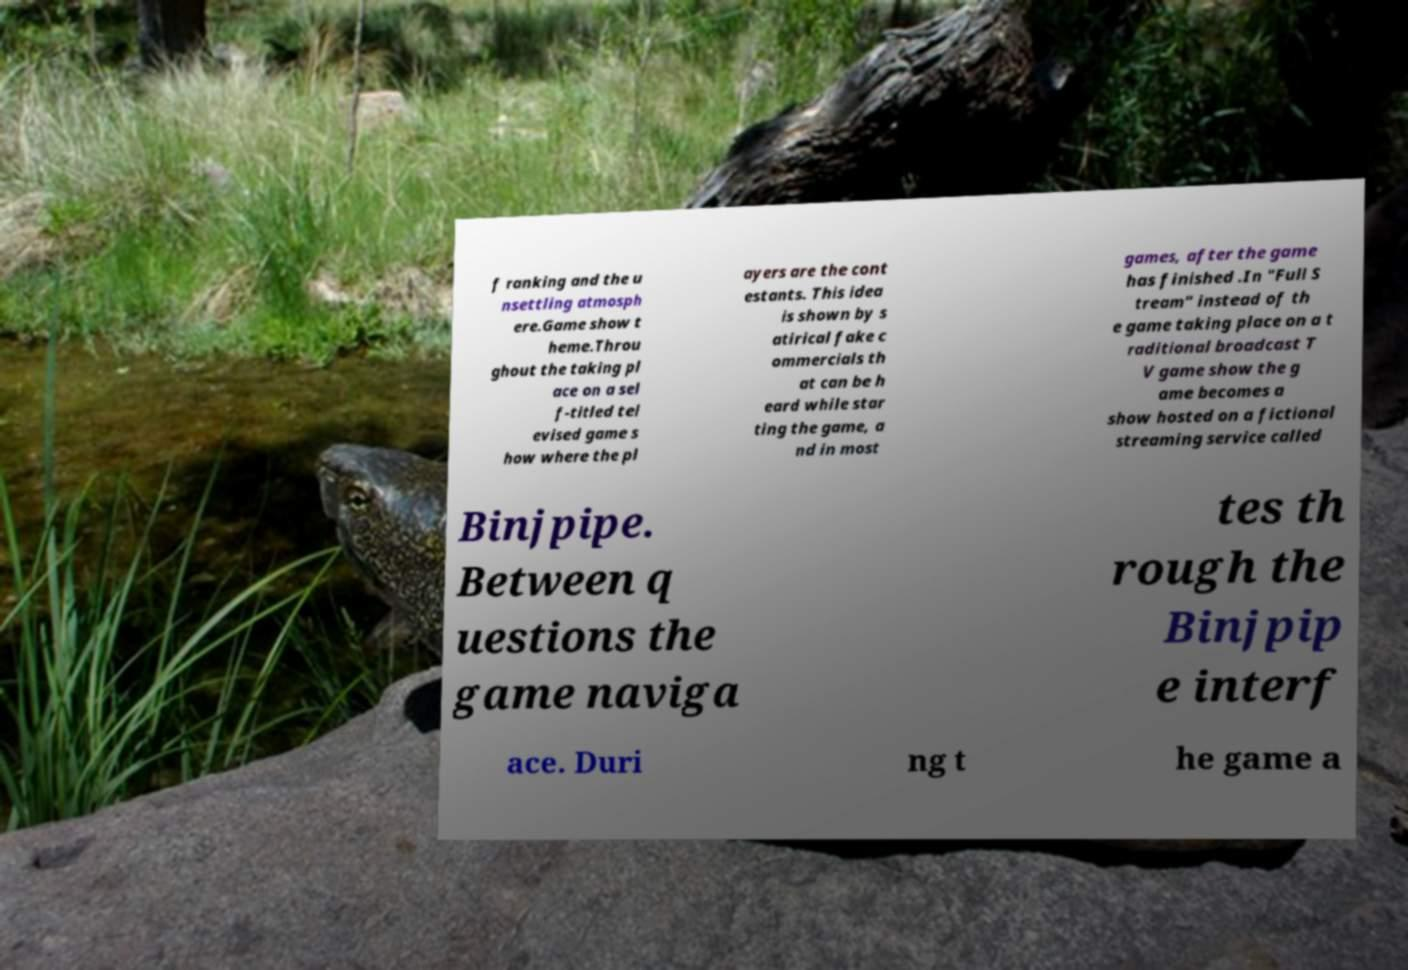For documentation purposes, I need the text within this image transcribed. Could you provide that? f ranking and the u nsettling atmosph ere.Game show t heme.Throu ghout the taking pl ace on a sel f-titled tel evised game s how where the pl ayers are the cont estants. This idea is shown by s atirical fake c ommercials th at can be h eard while star ting the game, a nd in most games, after the game has finished .In "Full S tream" instead of th e game taking place on a t raditional broadcast T V game show the g ame becomes a show hosted on a fictional streaming service called Binjpipe. Between q uestions the game naviga tes th rough the Binjpip e interf ace. Duri ng t he game a 